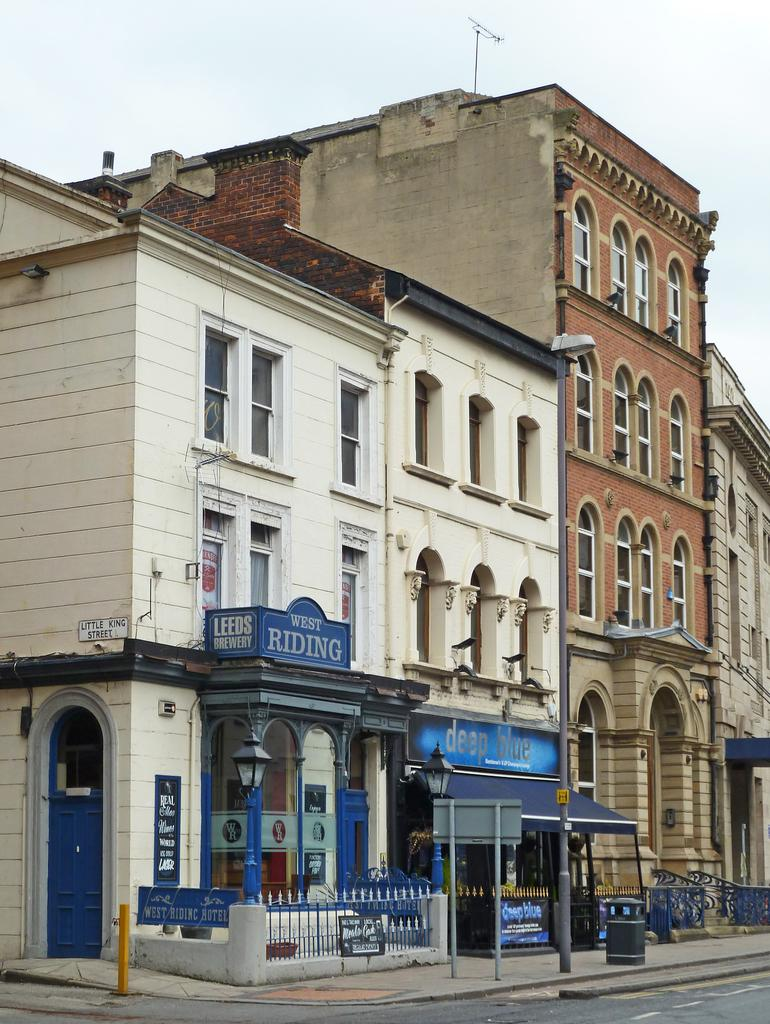What is the main feature of the image? There is a road in the image. What objects are near the road? There are boards and a railing near the road. What other object is near the road? There is a dustbin near the road. What can be seen in the background of the image? There are buildings and the sky visible in the background. What type of room can be seen on the stage in the image? There is no room or stage present in the image; it features a road with nearby objects and a background of buildings and sky. 